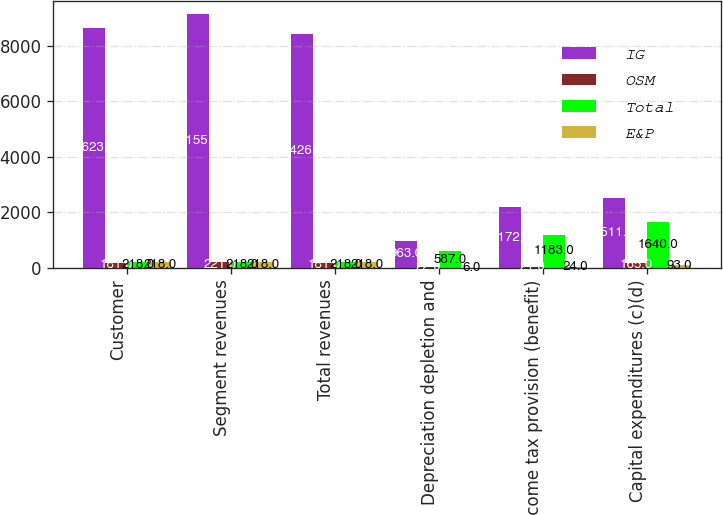Convert chart. <chart><loc_0><loc_0><loc_500><loc_500><stacked_bar_chart><ecel><fcel>Customer<fcel>Segment revenues<fcel>Total revenues<fcel>Depreciation depletion and<fcel>Income tax provision (benefit)<fcel>Capital expenditures (c)(d)<nl><fcel>IG<fcel>8623<fcel>9155<fcel>8426<fcel>963<fcel>2172<fcel>2511<nl><fcel>OSM<fcel>181<fcel>221<fcel>181<fcel>22<fcel>21<fcel>165<nl><fcel>Total<fcel>218<fcel>218<fcel>218<fcel>587<fcel>1183<fcel>1640<nl><fcel>E&P<fcel>218<fcel>218<fcel>218<fcel>6<fcel>24<fcel>93<nl></chart> 